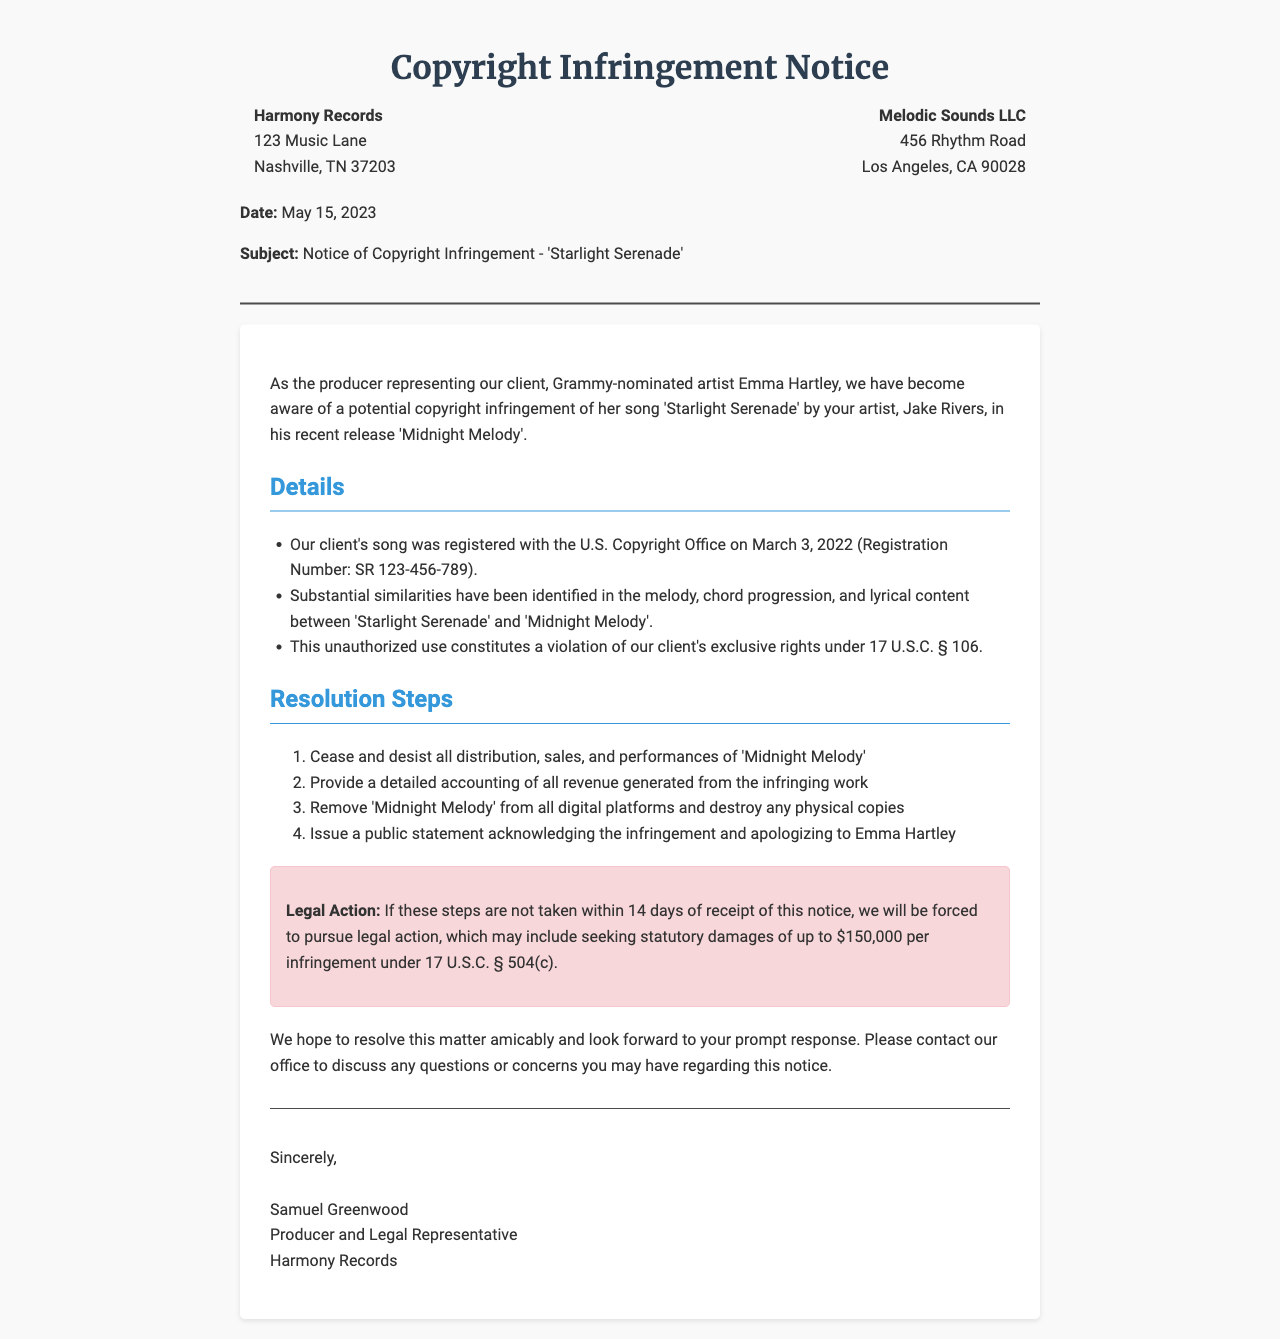What is the name of the artist represented by Harmony Records? The document states that the artist represented is Grammy-nominated Emma Hartley.
Answer: Emma Hartley What is the date of the copyright registration for 'Starlight Serenade'? The document specifies that 'Starlight Serenade' was registered on March 3, 2022.
Answer: March 3, 2022 What is the name of the infringing song? The document identifies the song that allegedly infringes on copyright as 'Midnight Melody'.
Answer: Midnight Melody What is the potential statutory damages amount mentioned for infringement? The document indicates that statutory damages may be sought up to $150,000 per infringement.
Answer: $150,000 How many steps are outlined for resolution in the notice? The document lists four steps that need to be taken for resolution.
Answer: Four What must Melodic Sounds LLC do within 14 days according to the notice? The document specifies that they must take the outlined resolution steps within 14 days.
Answer: Resolution steps Who is the sender of the notice? The document states that the sender of the notice is Samuel Greenwood, Producer and Legal Representative.
Answer: Samuel Greenwood What legal section is referenced regarding the exclusive rights violation? The document cites 17 U.S.C. § 106 as the legal section regarding exclusive rights.
Answer: 17 U.S.C. § 106 What tone does the sender wish to maintain regarding the outcome of the notice? The document expresses a desire to resolve the matter amicably.
Answer: Amicably 